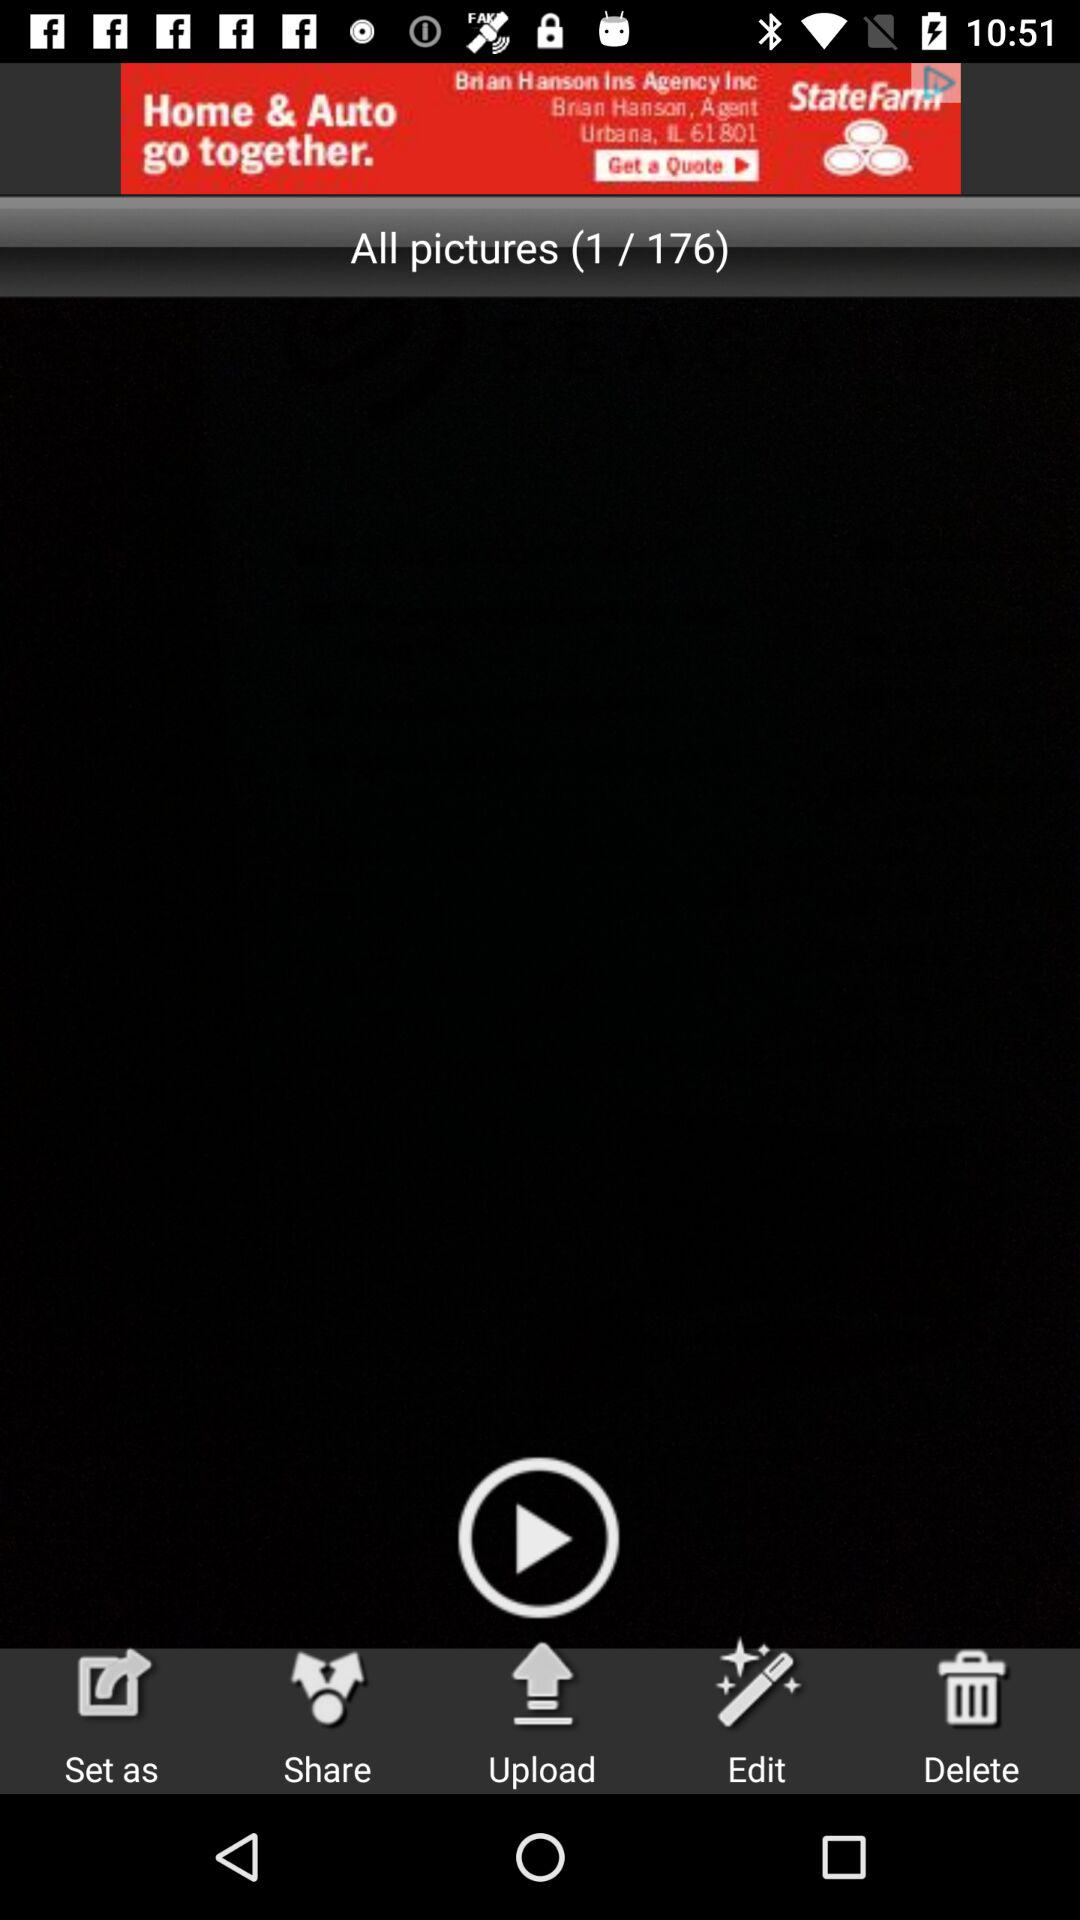What is the number of the open picture? The open picture is at number 1. 